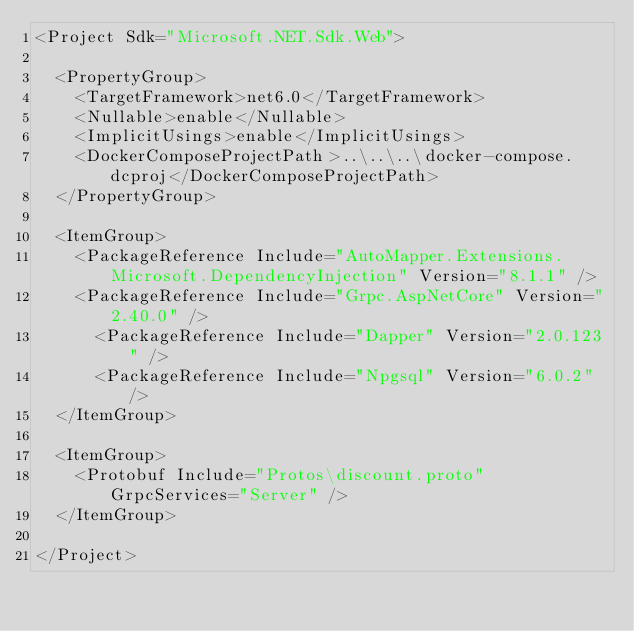<code> <loc_0><loc_0><loc_500><loc_500><_XML_><Project Sdk="Microsoft.NET.Sdk.Web">

  <PropertyGroup>
    <TargetFramework>net6.0</TargetFramework>
    <Nullable>enable</Nullable>
    <ImplicitUsings>enable</ImplicitUsings>
    <DockerComposeProjectPath>..\..\..\docker-compose.dcproj</DockerComposeProjectPath>
  </PropertyGroup>

  <ItemGroup>
    <PackageReference Include="AutoMapper.Extensions.Microsoft.DependencyInjection" Version="8.1.1" />
    <PackageReference Include="Grpc.AspNetCore" Version="2.40.0" />
	  <PackageReference Include="Dapper" Version="2.0.123" />
	  <PackageReference Include="Npgsql" Version="6.0.2" />
  </ItemGroup>

  <ItemGroup>
    <Protobuf Include="Protos\discount.proto" GrpcServices="Server" />
  </ItemGroup>

</Project>
</code> 